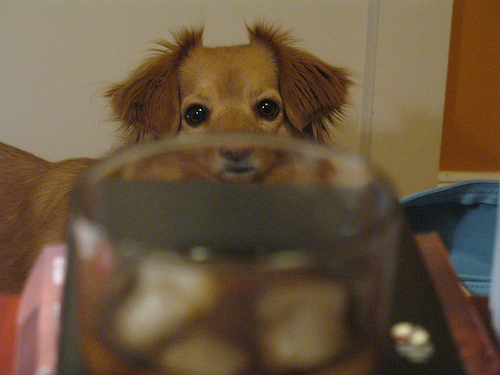<image>
Is the dog on the glass? No. The dog is not positioned on the glass. They may be near each other, but the dog is not supported by or resting on top of the glass. 